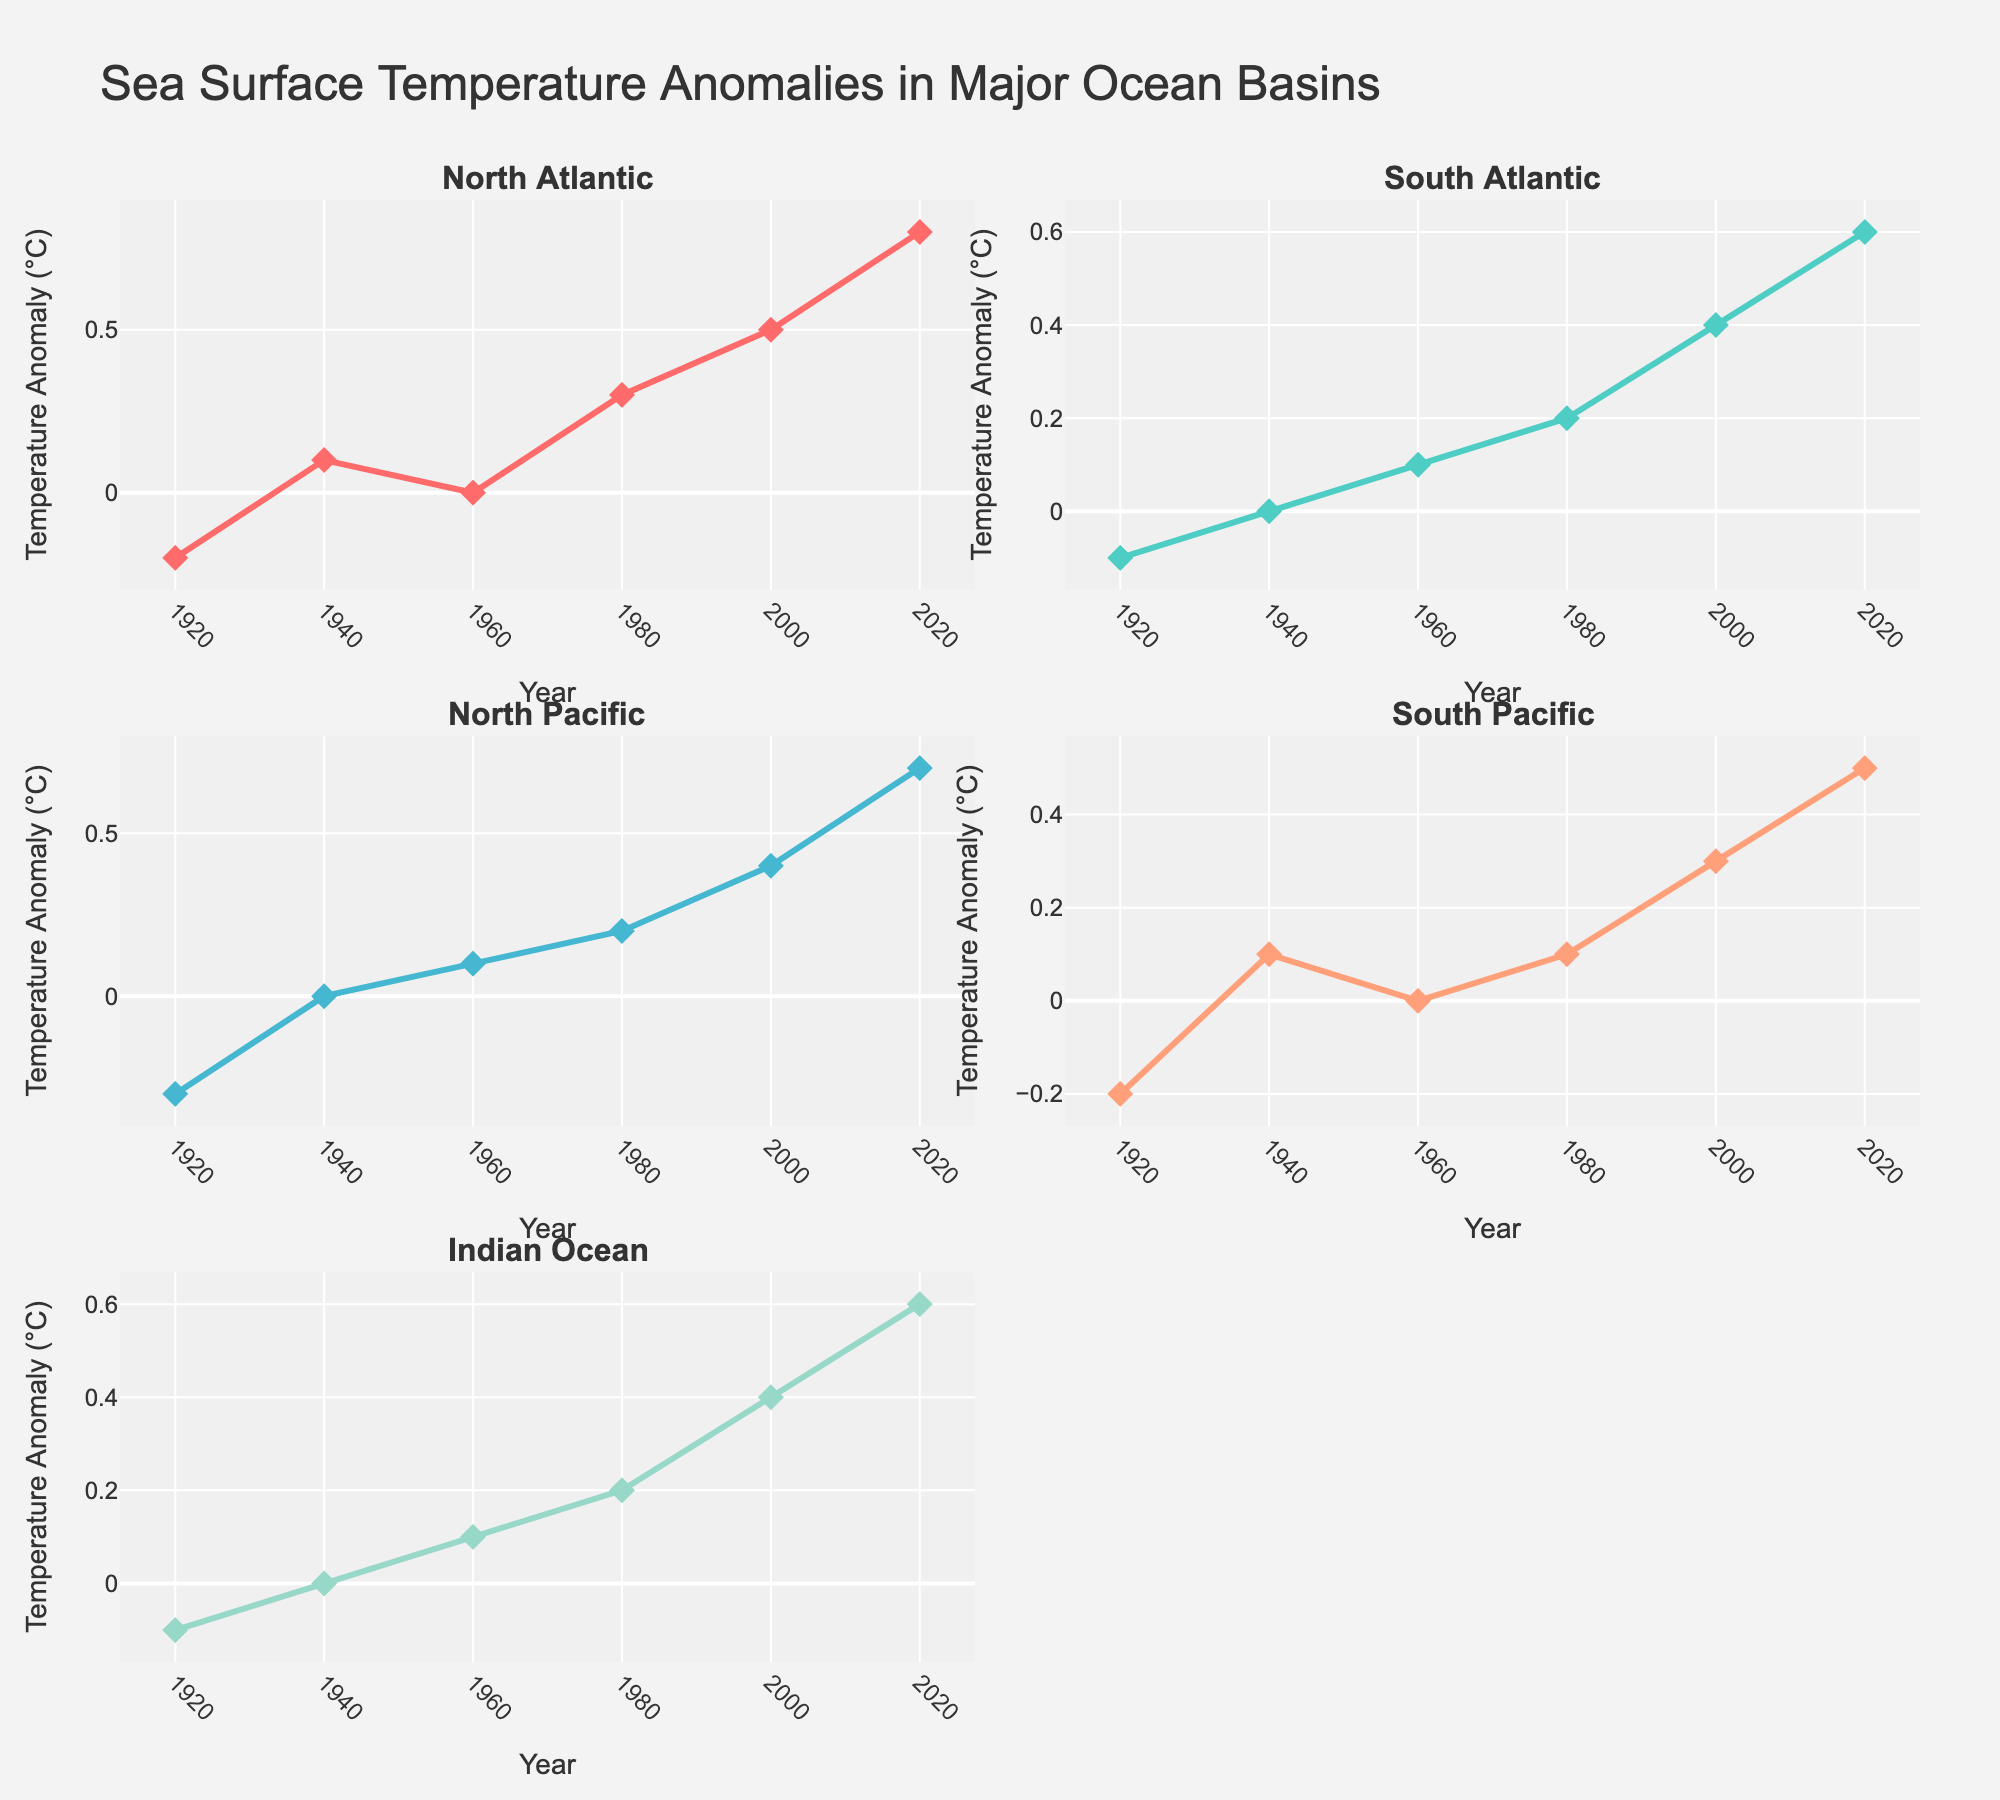When does the North Pacific see its highest temperature anomaly? The North Pacific's highest temperature anomaly appears where its data series reaches its peak value. Reviewing the plot, we can observe this peak occurs in the year 2020.
Answer: 2020 Which ocean basin shows the most significant increase in temperature anomalies between 1980 and 2000? This question requires us to compare the temperature anomaly increase across all ocean basins from 1980 to 2000. By observing the figure, we see: North Atlantic (0.3 to 0.5), South Atlantic (0.2 to 0.4), North Pacific (0.2 to 0.4), South Pacific (0.1 to 0.3), and Indian Ocean (0.2 to 0.4). Each ocean basin starts and ends with different anomaly values, but the North Atlantic shows the largest increase of 0.2.
Answer: North Atlantic Which year had an approximate temperature anomaly of zero for the Indian Ocean? Checking the Indian Ocean subplot (bottom right), we notice that the temperature anomaly is very close to zero around the year 1940.
Answer: 1940 How much did the North Atlantic temperature anomaly change from 1960 to 2020? To determine this, subtract the North Atlantic anomaly in 1960 (-0.0) from its value in 2020 (0.8), giving us a change of 0.8.
Answer: 0.8 What is the general trend of temperature anomalies in the South Atlantic from 1920 to 2020? Observing the South Atlantic plot (top right), the temperature anomalies show a consistent increase over the time period from 1920 (-0.1) to 2020 (0.6). The trend is overall positive.
Answer: Increasingtrend Which ocean basin had the lowest temperature anomaly in 1920? Reviewing all subplots for the year 1920, the North Pacific basin shows the lowest temperature anomaly at -0.3.
Answer: North Pacific How do the temperature anomalies of the North and South Pacific compare in 2020? In 2020, the North Pacific anomaly is 0.7, whereas the South Pacific anomaly is 0.5, making the North Pacific's anomaly greater.
Answer: North Pacific is greater Between which periods did the Indian Ocean temperature anomaly increase by 0.3°C? For the Indian Ocean, large increments can be seen. We note from 1980 (0.2) to 2020 (0.6) the anomaly increases by 0.4, and from 1960 (0.1) to 2020 (0.6) by 0.5. Only between 2000 (0.4) to 2020 (0.6), right interval gives 0.2, which matches the increase closely.
Answer: 2000 to 2020 What was the rate of change of the North Atlantic temperature anomaly from 2000 to 2020? Determine the change in anomaly (from 0.5 in 2000 to 0.8 in 2020) divided by the number of years (20 years). So, the rate of change is (0.8 - 0.5) / 20 = 0.015 per year.
Answer: 0.015 per year 